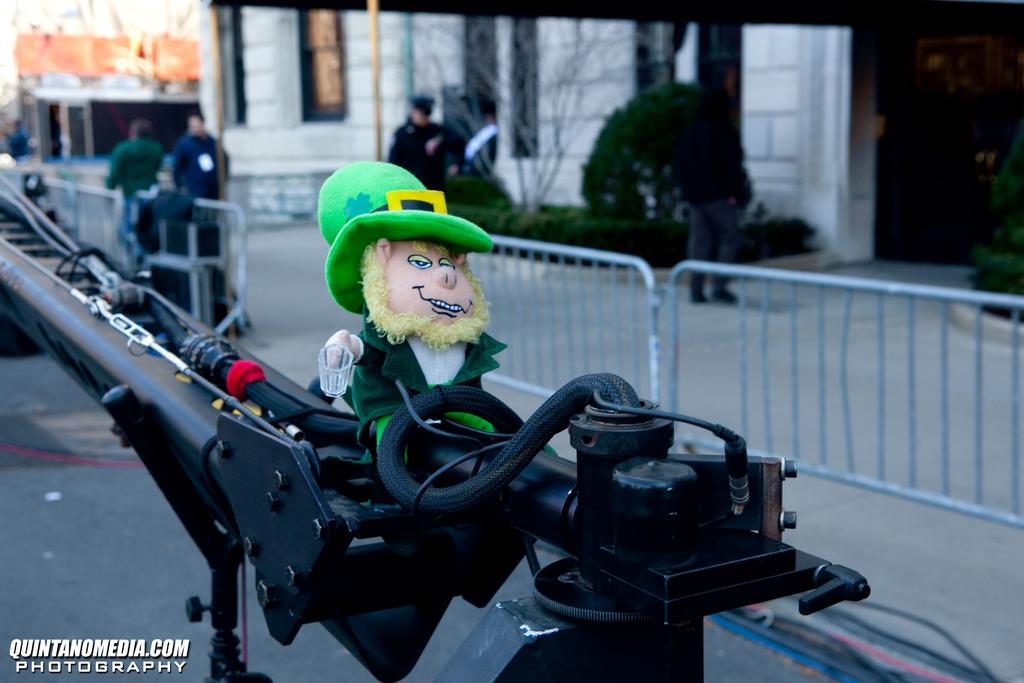What is the doll positioned on in the image? There is a doll on a crane in the image. What might be used to control traffic or access in the image? Barricades are present in the image. What type of pathway is visible in the image? There is a road in the image. Can you describe the people visible in the image? There are people visible in the image. What type of vegetation is present in the image? There are plants and a tree in the image. What can be seen in the background of the image? There are buildings in the background of the image. What type of arm is visible on the tree in the image? There is no arm visible on the tree in the image. Are there any icicles hanging from the buildings in the background? There is no mention of icicles in the image, and they are not visible in the provided facts. 